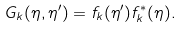<formula> <loc_0><loc_0><loc_500><loc_500>G _ { k } ( \eta , \eta ^ { \prime } ) = f _ { k } ( \eta ^ { \prime } ) f _ { k } ^ { * } ( \eta ) .</formula> 